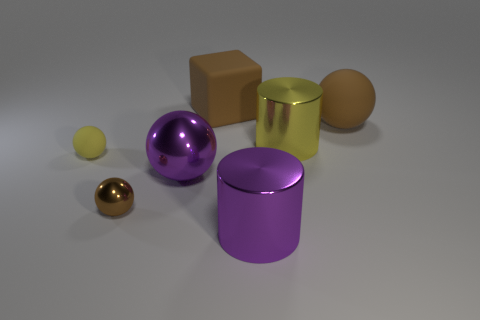There is another big rubber thing that is the same shape as the yellow matte object; what is its color?
Keep it short and to the point. Brown. There is another brown object that is the same shape as the small brown shiny thing; what is its size?
Ensure brevity in your answer.  Large. What color is the large metallic thing that is to the left of the large thing that is in front of the small brown metallic ball?
Give a very brief answer. Purple. Is there anything else that is the same shape as the yellow shiny thing?
Make the answer very short. Yes. Are there the same number of purple spheres that are behind the purple metal ball and purple shiny things that are behind the yellow sphere?
Offer a very short reply. Yes. How many balls are either big matte things or brown metallic things?
Make the answer very short. 2. What number of other things are the same material as the large cube?
Make the answer very short. 2. There is a brown matte thing that is left of the purple metal cylinder; what is its shape?
Offer a terse response. Cube. What material is the brown ball that is in front of the big metallic cylinder that is behind the big purple cylinder?
Make the answer very short. Metal. Are there more metal spheres behind the large metal ball than big green metal cylinders?
Give a very brief answer. No. 